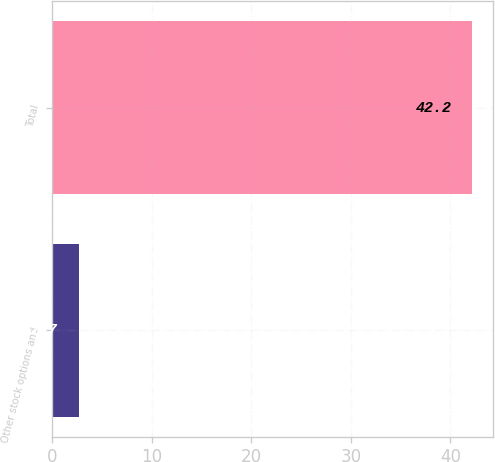<chart> <loc_0><loc_0><loc_500><loc_500><bar_chart><fcel>Other stock options and<fcel>Total<nl><fcel>2.7<fcel>42.2<nl></chart> 